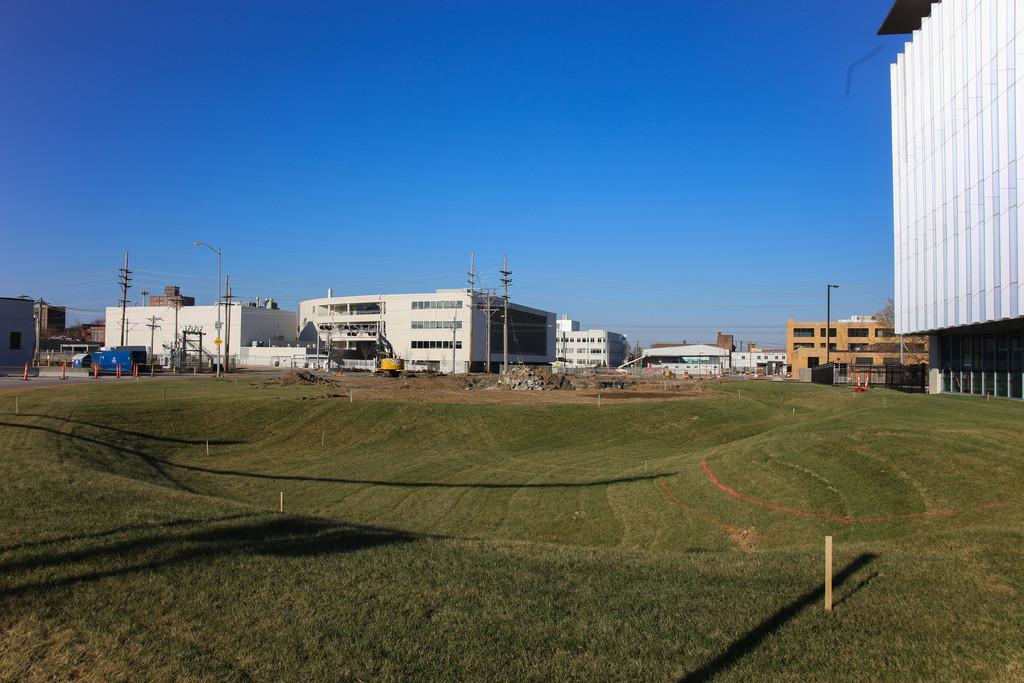What type of structures can be seen in the image? There are buildings in the image. What else can be seen in the image besides buildings? There are poles, lights, wires, traffic cones, and grass on the ground visible in the image. What is the purpose of the poles in the image? The poles are likely used to support the lights and wires in the image. What is visible in the background of the image? The sky is visible in the background of the image. How does the distribution of the toad affect the traffic cones in the image? There is no toad present in the image, so its distribution cannot affect the traffic cones. 